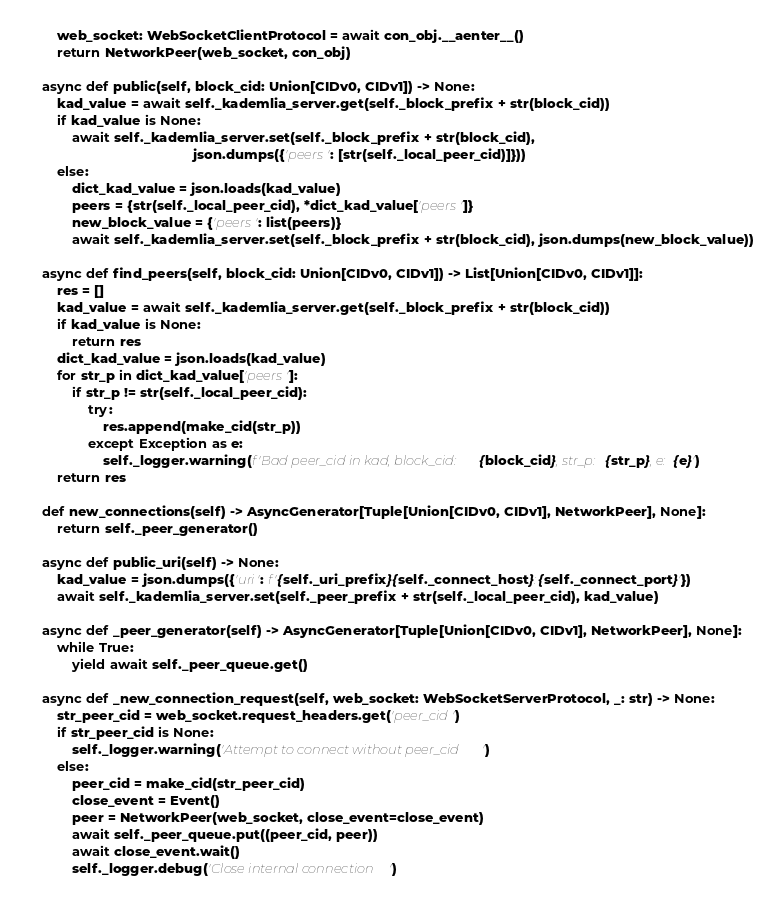Convert code to text. <code><loc_0><loc_0><loc_500><loc_500><_Python_>        web_socket: WebSocketClientProtocol = await con_obj.__aenter__()
        return NetworkPeer(web_socket, con_obj)

    async def public(self, block_cid: Union[CIDv0, CIDv1]) -> None:
        kad_value = await self._kademlia_server.get(self._block_prefix + str(block_cid))
        if kad_value is None:
            await self._kademlia_server.set(self._block_prefix + str(block_cid),
                                            json.dumps({'peers': [str(self._local_peer_cid)]}))
        else:
            dict_kad_value = json.loads(kad_value)
            peers = {str(self._local_peer_cid), *dict_kad_value['peers']}
            new_block_value = {'peers': list(peers)}
            await self._kademlia_server.set(self._block_prefix + str(block_cid), json.dumps(new_block_value))

    async def find_peers(self, block_cid: Union[CIDv0, CIDv1]) -> List[Union[CIDv0, CIDv1]]:
        res = []
        kad_value = await self._kademlia_server.get(self._block_prefix + str(block_cid))
        if kad_value is None:
            return res
        dict_kad_value = json.loads(kad_value)
        for str_p in dict_kad_value['peers']:
            if str_p != str(self._local_peer_cid):
                try:
                    res.append(make_cid(str_p))
                except Exception as e:
                    self._logger.warning(f'Bad peer_cid in kad, block_cid: {block_cid}, str_p: {str_p}, e: {e}')
        return res

    def new_connections(self) -> AsyncGenerator[Tuple[Union[CIDv0, CIDv1], NetworkPeer], None]:
        return self._peer_generator()

    async def public_uri(self) -> None:
        kad_value = json.dumps({'uri': f'{self._uri_prefix}{self._connect_host}:{self._connect_port}'})
        await self._kademlia_server.set(self._peer_prefix + str(self._local_peer_cid), kad_value)

    async def _peer_generator(self) -> AsyncGenerator[Tuple[Union[CIDv0, CIDv1], NetworkPeer], None]:
        while True:
            yield await self._peer_queue.get()

    async def _new_connection_request(self, web_socket: WebSocketServerProtocol, _: str) -> None:
        str_peer_cid = web_socket.request_headers.get('peer_cid')
        if str_peer_cid is None:
            self._logger.warning('Attempt to connect without peer_cid')
        else:
            peer_cid = make_cid(str_peer_cid)
            close_event = Event()
            peer = NetworkPeer(web_socket, close_event=close_event)
            await self._peer_queue.put((peer_cid, peer))
            await close_event.wait()
            self._logger.debug('Close internal connection')
</code> 